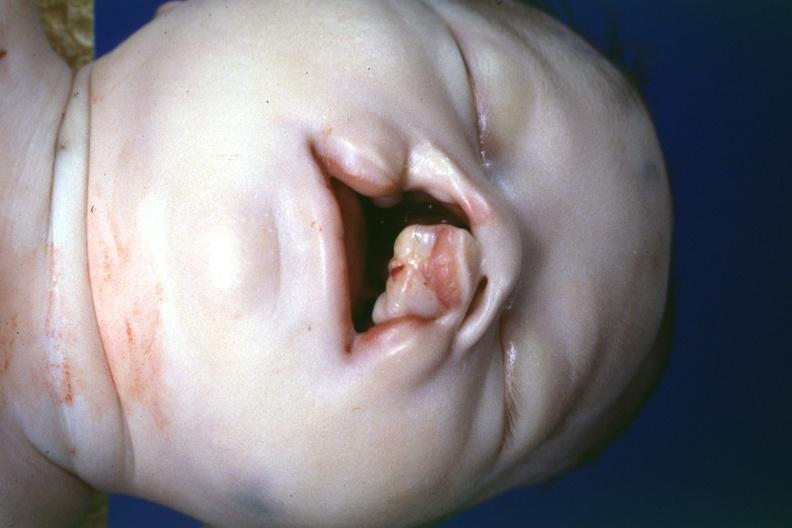does this image show left side lesion?
Answer the question using a single word or phrase. Yes 